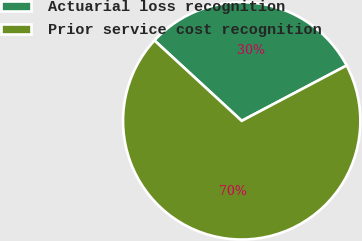Convert chart. <chart><loc_0><loc_0><loc_500><loc_500><pie_chart><fcel>Actuarial loss recognition<fcel>Prior service cost recognition<nl><fcel>30.42%<fcel>69.58%<nl></chart> 